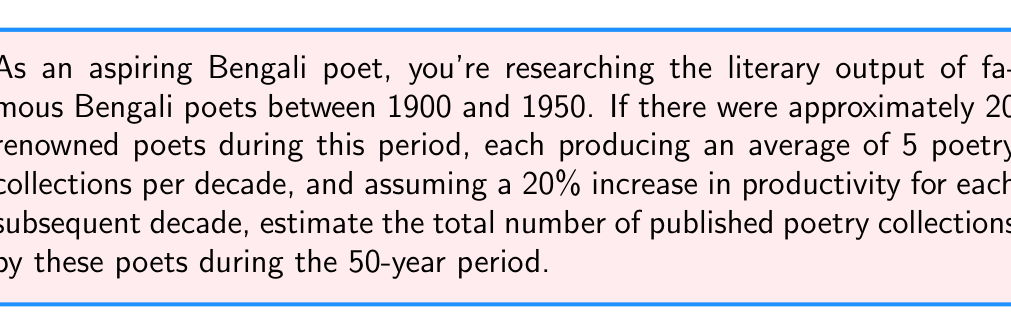Can you solve this math problem? Let's approach this step-by-step:

1) First, let's calculate the number of collections per poet for each decade:

   1900-1910: 5 collections (base)
   1911-1920: $5 \times 1.2 = 6$ collections
   1921-1930: $6 \times 1.2 = 7.2$ collections
   1931-1940: $7.2 \times 1.2 = 8.64$ collections
   1941-1950: $8.64 \times 1.2 = 10.368$ collections

2) Now, let's sum up the total collections per poet over the 50 years:

   $5 + 6 + 7.2 + 8.64 + 10.368 = 37.208$ collections per poet

3) Since there were 20 renowned poets, we multiply this by 20:

   $37.208 \times 20 = 744.16$ total collections

4) As we're estimating, let's round this to the nearest whole number:

   744 total collections
Answer: 744 poetry collections 